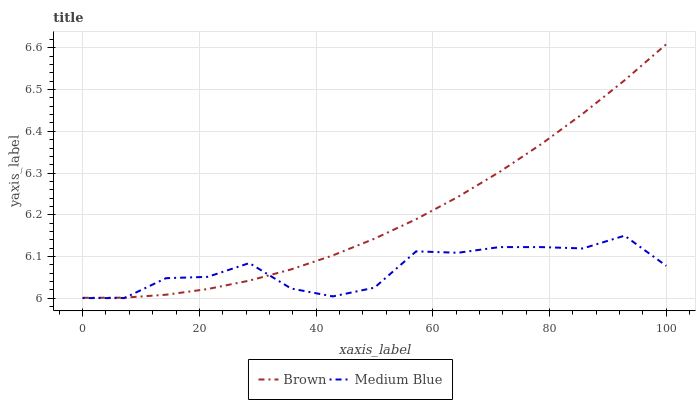Does Medium Blue have the minimum area under the curve?
Answer yes or no. Yes. Does Brown have the maximum area under the curve?
Answer yes or no. Yes. Does Medium Blue have the maximum area under the curve?
Answer yes or no. No. Is Brown the smoothest?
Answer yes or no. Yes. Is Medium Blue the roughest?
Answer yes or no. Yes. Is Medium Blue the smoothest?
Answer yes or no. No. Does Medium Blue have the lowest value?
Answer yes or no. Yes. Does Brown have the highest value?
Answer yes or no. Yes. Does Medium Blue have the highest value?
Answer yes or no. No. Does Brown intersect Medium Blue?
Answer yes or no. Yes. Is Brown less than Medium Blue?
Answer yes or no. No. Is Brown greater than Medium Blue?
Answer yes or no. No. 